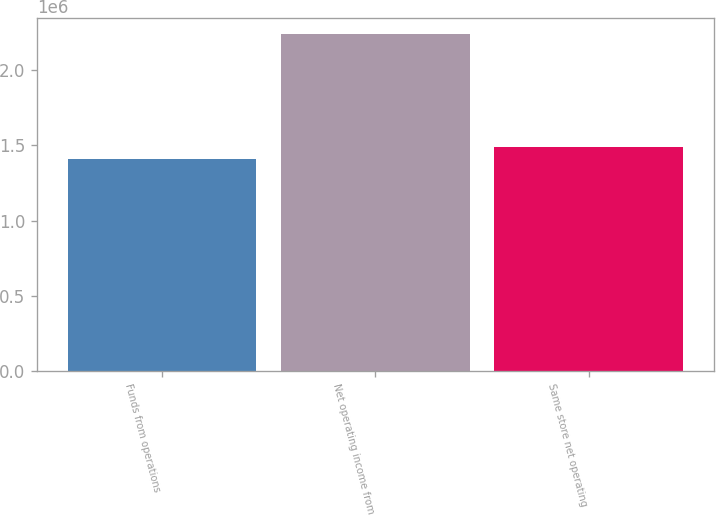Convert chart. <chart><loc_0><loc_0><loc_500><loc_500><bar_chart><fcel>Funds from operations<fcel>Net operating income from<fcel>Same store net operating<nl><fcel>1.40964e+06<fcel>2.23757e+06<fcel>1.49243e+06<nl></chart> 